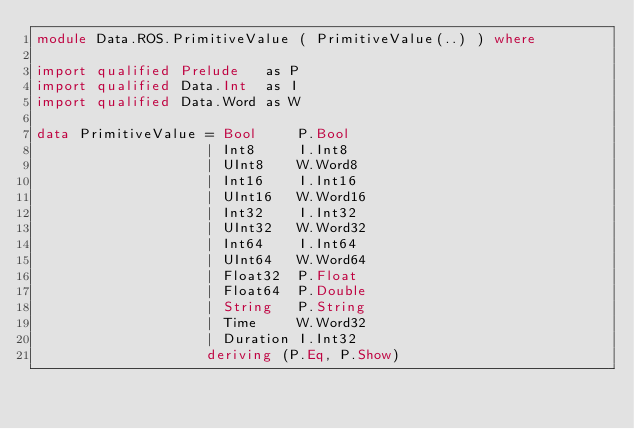<code> <loc_0><loc_0><loc_500><loc_500><_Haskell_>module Data.ROS.PrimitiveValue ( PrimitiveValue(..) ) where

import qualified Prelude   as P
import qualified Data.Int  as I
import qualified Data.Word as W

data PrimitiveValue = Bool     P.Bool
                    | Int8     I.Int8
                    | UInt8    W.Word8
                    | Int16    I.Int16
                    | UInt16   W.Word16
                    | Int32    I.Int32
                    | UInt32   W.Word32
                    | Int64    I.Int64
                    | UInt64   W.Word64
                    | Float32  P.Float
                    | Float64  P.Double
                    | String   P.String
                    | Time     W.Word32
                    | Duration I.Int32
                    deriving (P.Eq, P.Show)

</code> 